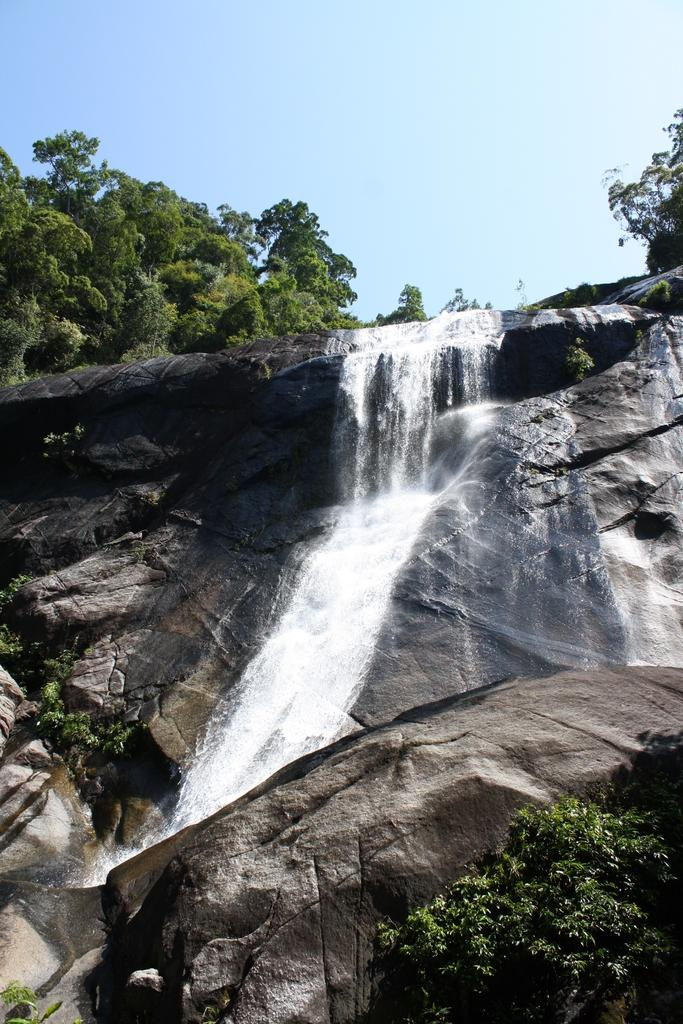What natural feature is the main subject of the image? There is a waterfall in the image. What else can be seen in the sky in the image? There is a sky visible in the image. What type of vegetation is present in the image? There are many trees and plants in the image. How many beds can be seen in the image? There are no beds present in the image. What type of mouth is visible in the image? There is no mouth visible in the image. 